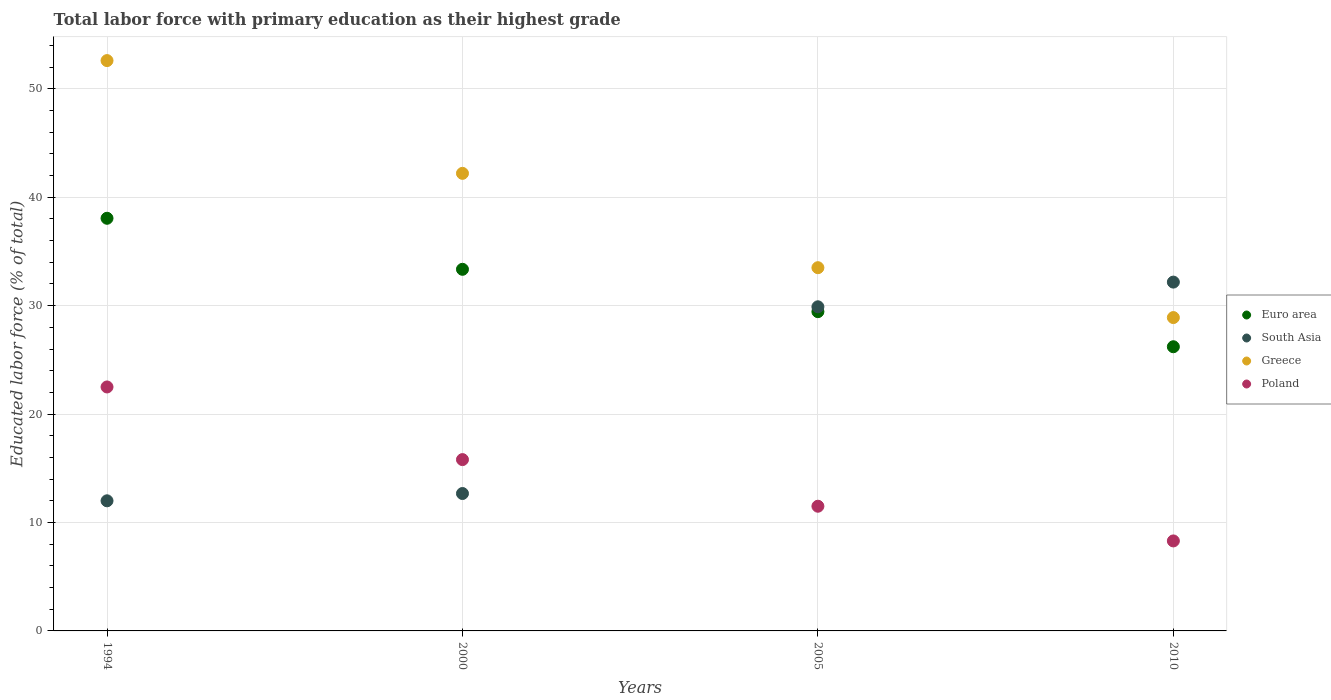How many different coloured dotlines are there?
Your answer should be very brief. 4. Is the number of dotlines equal to the number of legend labels?
Provide a succinct answer. Yes. What is the percentage of total labor force with primary education in Euro area in 2000?
Your answer should be very brief. 33.35. Across all years, what is the minimum percentage of total labor force with primary education in Greece?
Offer a very short reply. 28.9. In which year was the percentage of total labor force with primary education in South Asia minimum?
Your answer should be compact. 1994. What is the total percentage of total labor force with primary education in South Asia in the graph?
Keep it short and to the point. 86.74. What is the difference between the percentage of total labor force with primary education in Euro area in 1994 and that in 2000?
Provide a succinct answer. 4.71. What is the difference between the percentage of total labor force with primary education in Greece in 2005 and the percentage of total labor force with primary education in Euro area in 2000?
Your answer should be very brief. 0.15. What is the average percentage of total labor force with primary education in Poland per year?
Give a very brief answer. 14.53. In the year 2010, what is the difference between the percentage of total labor force with primary education in Poland and percentage of total labor force with primary education in South Asia?
Ensure brevity in your answer.  -23.87. In how many years, is the percentage of total labor force with primary education in Euro area greater than 44 %?
Provide a short and direct response. 0. What is the ratio of the percentage of total labor force with primary education in South Asia in 2000 to that in 2010?
Offer a terse response. 0.39. Is the difference between the percentage of total labor force with primary education in Poland in 1994 and 2005 greater than the difference between the percentage of total labor force with primary education in South Asia in 1994 and 2005?
Provide a short and direct response. Yes. What is the difference between the highest and the second highest percentage of total labor force with primary education in South Asia?
Make the answer very short. 2.28. What is the difference between the highest and the lowest percentage of total labor force with primary education in Euro area?
Offer a very short reply. 11.85. In how many years, is the percentage of total labor force with primary education in Poland greater than the average percentage of total labor force with primary education in Poland taken over all years?
Give a very brief answer. 2. Is it the case that in every year, the sum of the percentage of total labor force with primary education in South Asia and percentage of total labor force with primary education in Greece  is greater than the sum of percentage of total labor force with primary education in Euro area and percentage of total labor force with primary education in Poland?
Your answer should be compact. Yes. How many years are there in the graph?
Your answer should be very brief. 4. What is the difference between two consecutive major ticks on the Y-axis?
Offer a very short reply. 10. Are the values on the major ticks of Y-axis written in scientific E-notation?
Provide a short and direct response. No. Does the graph contain any zero values?
Make the answer very short. No. Does the graph contain grids?
Ensure brevity in your answer.  Yes. Where does the legend appear in the graph?
Offer a very short reply. Center right. How many legend labels are there?
Offer a very short reply. 4. What is the title of the graph?
Provide a short and direct response. Total labor force with primary education as their highest grade. Does "East Asia (developing only)" appear as one of the legend labels in the graph?
Your answer should be compact. No. What is the label or title of the Y-axis?
Keep it short and to the point. Educated labor force (% of total). What is the Educated labor force (% of total) in Euro area in 1994?
Your response must be concise. 38.06. What is the Educated labor force (% of total) in Greece in 1994?
Provide a short and direct response. 52.6. What is the Educated labor force (% of total) of Euro area in 2000?
Your answer should be compact. 33.35. What is the Educated labor force (% of total) in South Asia in 2000?
Offer a terse response. 12.67. What is the Educated labor force (% of total) in Greece in 2000?
Your response must be concise. 42.2. What is the Educated labor force (% of total) in Poland in 2000?
Your answer should be very brief. 15.8. What is the Educated labor force (% of total) of Euro area in 2005?
Provide a short and direct response. 29.44. What is the Educated labor force (% of total) of South Asia in 2005?
Keep it short and to the point. 29.89. What is the Educated labor force (% of total) in Greece in 2005?
Ensure brevity in your answer.  33.5. What is the Educated labor force (% of total) in Euro area in 2010?
Your answer should be compact. 26.21. What is the Educated labor force (% of total) in South Asia in 2010?
Your answer should be compact. 32.17. What is the Educated labor force (% of total) of Greece in 2010?
Your answer should be compact. 28.9. What is the Educated labor force (% of total) of Poland in 2010?
Ensure brevity in your answer.  8.3. Across all years, what is the maximum Educated labor force (% of total) in Euro area?
Give a very brief answer. 38.06. Across all years, what is the maximum Educated labor force (% of total) of South Asia?
Provide a succinct answer. 32.17. Across all years, what is the maximum Educated labor force (% of total) of Greece?
Your response must be concise. 52.6. Across all years, what is the maximum Educated labor force (% of total) of Poland?
Keep it short and to the point. 22.5. Across all years, what is the minimum Educated labor force (% of total) in Euro area?
Your answer should be compact. 26.21. Across all years, what is the minimum Educated labor force (% of total) in Greece?
Provide a succinct answer. 28.9. Across all years, what is the minimum Educated labor force (% of total) of Poland?
Provide a succinct answer. 8.3. What is the total Educated labor force (% of total) in Euro area in the graph?
Keep it short and to the point. 127.06. What is the total Educated labor force (% of total) in South Asia in the graph?
Ensure brevity in your answer.  86.74. What is the total Educated labor force (% of total) in Greece in the graph?
Your response must be concise. 157.2. What is the total Educated labor force (% of total) of Poland in the graph?
Make the answer very short. 58.1. What is the difference between the Educated labor force (% of total) of Euro area in 1994 and that in 2000?
Make the answer very short. 4.71. What is the difference between the Educated labor force (% of total) of South Asia in 1994 and that in 2000?
Offer a terse response. -0.67. What is the difference between the Educated labor force (% of total) of Euro area in 1994 and that in 2005?
Your answer should be compact. 8.61. What is the difference between the Educated labor force (% of total) in South Asia in 1994 and that in 2005?
Your answer should be very brief. -17.89. What is the difference between the Educated labor force (% of total) in Poland in 1994 and that in 2005?
Make the answer very short. 11. What is the difference between the Educated labor force (% of total) in Euro area in 1994 and that in 2010?
Provide a succinct answer. 11.85. What is the difference between the Educated labor force (% of total) of South Asia in 1994 and that in 2010?
Keep it short and to the point. -20.17. What is the difference between the Educated labor force (% of total) in Greece in 1994 and that in 2010?
Offer a terse response. 23.7. What is the difference between the Educated labor force (% of total) in Euro area in 2000 and that in 2005?
Provide a succinct answer. 3.91. What is the difference between the Educated labor force (% of total) in South Asia in 2000 and that in 2005?
Give a very brief answer. -17.22. What is the difference between the Educated labor force (% of total) of Greece in 2000 and that in 2005?
Make the answer very short. 8.7. What is the difference between the Educated labor force (% of total) of Poland in 2000 and that in 2005?
Provide a succinct answer. 4.3. What is the difference between the Educated labor force (% of total) of Euro area in 2000 and that in 2010?
Your answer should be very brief. 7.14. What is the difference between the Educated labor force (% of total) in South Asia in 2000 and that in 2010?
Keep it short and to the point. -19.5. What is the difference between the Educated labor force (% of total) in Poland in 2000 and that in 2010?
Provide a short and direct response. 7.5. What is the difference between the Educated labor force (% of total) of Euro area in 2005 and that in 2010?
Ensure brevity in your answer.  3.23. What is the difference between the Educated labor force (% of total) of South Asia in 2005 and that in 2010?
Ensure brevity in your answer.  -2.28. What is the difference between the Educated labor force (% of total) in Greece in 2005 and that in 2010?
Offer a very short reply. 4.6. What is the difference between the Educated labor force (% of total) in Poland in 2005 and that in 2010?
Give a very brief answer. 3.2. What is the difference between the Educated labor force (% of total) in Euro area in 1994 and the Educated labor force (% of total) in South Asia in 2000?
Offer a terse response. 25.38. What is the difference between the Educated labor force (% of total) of Euro area in 1994 and the Educated labor force (% of total) of Greece in 2000?
Your answer should be compact. -4.14. What is the difference between the Educated labor force (% of total) of Euro area in 1994 and the Educated labor force (% of total) of Poland in 2000?
Provide a short and direct response. 22.26. What is the difference between the Educated labor force (% of total) of South Asia in 1994 and the Educated labor force (% of total) of Greece in 2000?
Your answer should be very brief. -30.2. What is the difference between the Educated labor force (% of total) in Greece in 1994 and the Educated labor force (% of total) in Poland in 2000?
Your response must be concise. 36.8. What is the difference between the Educated labor force (% of total) of Euro area in 1994 and the Educated labor force (% of total) of South Asia in 2005?
Give a very brief answer. 8.16. What is the difference between the Educated labor force (% of total) of Euro area in 1994 and the Educated labor force (% of total) of Greece in 2005?
Give a very brief answer. 4.56. What is the difference between the Educated labor force (% of total) in Euro area in 1994 and the Educated labor force (% of total) in Poland in 2005?
Ensure brevity in your answer.  26.56. What is the difference between the Educated labor force (% of total) in South Asia in 1994 and the Educated labor force (% of total) in Greece in 2005?
Your answer should be compact. -21.5. What is the difference between the Educated labor force (% of total) of South Asia in 1994 and the Educated labor force (% of total) of Poland in 2005?
Your answer should be very brief. 0.5. What is the difference between the Educated labor force (% of total) in Greece in 1994 and the Educated labor force (% of total) in Poland in 2005?
Make the answer very short. 41.1. What is the difference between the Educated labor force (% of total) in Euro area in 1994 and the Educated labor force (% of total) in South Asia in 2010?
Your answer should be very brief. 5.89. What is the difference between the Educated labor force (% of total) of Euro area in 1994 and the Educated labor force (% of total) of Greece in 2010?
Provide a succinct answer. 9.16. What is the difference between the Educated labor force (% of total) of Euro area in 1994 and the Educated labor force (% of total) of Poland in 2010?
Your response must be concise. 29.76. What is the difference between the Educated labor force (% of total) in South Asia in 1994 and the Educated labor force (% of total) in Greece in 2010?
Your answer should be very brief. -16.9. What is the difference between the Educated labor force (% of total) in Greece in 1994 and the Educated labor force (% of total) in Poland in 2010?
Give a very brief answer. 44.3. What is the difference between the Educated labor force (% of total) of Euro area in 2000 and the Educated labor force (% of total) of South Asia in 2005?
Offer a terse response. 3.46. What is the difference between the Educated labor force (% of total) in Euro area in 2000 and the Educated labor force (% of total) in Greece in 2005?
Offer a terse response. -0.15. What is the difference between the Educated labor force (% of total) of Euro area in 2000 and the Educated labor force (% of total) of Poland in 2005?
Give a very brief answer. 21.85. What is the difference between the Educated labor force (% of total) in South Asia in 2000 and the Educated labor force (% of total) in Greece in 2005?
Offer a terse response. -20.83. What is the difference between the Educated labor force (% of total) in South Asia in 2000 and the Educated labor force (% of total) in Poland in 2005?
Offer a terse response. 1.17. What is the difference between the Educated labor force (% of total) in Greece in 2000 and the Educated labor force (% of total) in Poland in 2005?
Your response must be concise. 30.7. What is the difference between the Educated labor force (% of total) in Euro area in 2000 and the Educated labor force (% of total) in South Asia in 2010?
Offer a very short reply. 1.18. What is the difference between the Educated labor force (% of total) in Euro area in 2000 and the Educated labor force (% of total) in Greece in 2010?
Give a very brief answer. 4.45. What is the difference between the Educated labor force (% of total) of Euro area in 2000 and the Educated labor force (% of total) of Poland in 2010?
Offer a terse response. 25.05. What is the difference between the Educated labor force (% of total) of South Asia in 2000 and the Educated labor force (% of total) of Greece in 2010?
Ensure brevity in your answer.  -16.23. What is the difference between the Educated labor force (% of total) of South Asia in 2000 and the Educated labor force (% of total) of Poland in 2010?
Keep it short and to the point. 4.37. What is the difference between the Educated labor force (% of total) in Greece in 2000 and the Educated labor force (% of total) in Poland in 2010?
Give a very brief answer. 33.9. What is the difference between the Educated labor force (% of total) in Euro area in 2005 and the Educated labor force (% of total) in South Asia in 2010?
Ensure brevity in your answer.  -2.73. What is the difference between the Educated labor force (% of total) of Euro area in 2005 and the Educated labor force (% of total) of Greece in 2010?
Keep it short and to the point. 0.54. What is the difference between the Educated labor force (% of total) in Euro area in 2005 and the Educated labor force (% of total) in Poland in 2010?
Keep it short and to the point. 21.14. What is the difference between the Educated labor force (% of total) of South Asia in 2005 and the Educated labor force (% of total) of Poland in 2010?
Make the answer very short. 21.59. What is the difference between the Educated labor force (% of total) in Greece in 2005 and the Educated labor force (% of total) in Poland in 2010?
Make the answer very short. 25.2. What is the average Educated labor force (% of total) of Euro area per year?
Keep it short and to the point. 31.77. What is the average Educated labor force (% of total) in South Asia per year?
Give a very brief answer. 21.68. What is the average Educated labor force (% of total) in Greece per year?
Offer a very short reply. 39.3. What is the average Educated labor force (% of total) in Poland per year?
Ensure brevity in your answer.  14.53. In the year 1994, what is the difference between the Educated labor force (% of total) in Euro area and Educated labor force (% of total) in South Asia?
Keep it short and to the point. 26.06. In the year 1994, what is the difference between the Educated labor force (% of total) of Euro area and Educated labor force (% of total) of Greece?
Make the answer very short. -14.54. In the year 1994, what is the difference between the Educated labor force (% of total) in Euro area and Educated labor force (% of total) in Poland?
Your answer should be very brief. 15.56. In the year 1994, what is the difference between the Educated labor force (% of total) of South Asia and Educated labor force (% of total) of Greece?
Provide a short and direct response. -40.6. In the year 1994, what is the difference between the Educated labor force (% of total) in South Asia and Educated labor force (% of total) in Poland?
Make the answer very short. -10.5. In the year 1994, what is the difference between the Educated labor force (% of total) of Greece and Educated labor force (% of total) of Poland?
Offer a very short reply. 30.1. In the year 2000, what is the difference between the Educated labor force (% of total) of Euro area and Educated labor force (% of total) of South Asia?
Your answer should be compact. 20.68. In the year 2000, what is the difference between the Educated labor force (% of total) in Euro area and Educated labor force (% of total) in Greece?
Your answer should be very brief. -8.85. In the year 2000, what is the difference between the Educated labor force (% of total) of Euro area and Educated labor force (% of total) of Poland?
Your answer should be very brief. 17.55. In the year 2000, what is the difference between the Educated labor force (% of total) of South Asia and Educated labor force (% of total) of Greece?
Your answer should be compact. -29.53. In the year 2000, what is the difference between the Educated labor force (% of total) of South Asia and Educated labor force (% of total) of Poland?
Provide a short and direct response. -3.13. In the year 2000, what is the difference between the Educated labor force (% of total) of Greece and Educated labor force (% of total) of Poland?
Give a very brief answer. 26.4. In the year 2005, what is the difference between the Educated labor force (% of total) of Euro area and Educated labor force (% of total) of South Asia?
Your answer should be very brief. -0.45. In the year 2005, what is the difference between the Educated labor force (% of total) in Euro area and Educated labor force (% of total) in Greece?
Make the answer very short. -4.06. In the year 2005, what is the difference between the Educated labor force (% of total) of Euro area and Educated labor force (% of total) of Poland?
Your response must be concise. 17.94. In the year 2005, what is the difference between the Educated labor force (% of total) in South Asia and Educated labor force (% of total) in Greece?
Ensure brevity in your answer.  -3.61. In the year 2005, what is the difference between the Educated labor force (% of total) in South Asia and Educated labor force (% of total) in Poland?
Make the answer very short. 18.39. In the year 2005, what is the difference between the Educated labor force (% of total) of Greece and Educated labor force (% of total) of Poland?
Provide a succinct answer. 22. In the year 2010, what is the difference between the Educated labor force (% of total) in Euro area and Educated labor force (% of total) in South Asia?
Keep it short and to the point. -5.96. In the year 2010, what is the difference between the Educated labor force (% of total) in Euro area and Educated labor force (% of total) in Greece?
Provide a short and direct response. -2.69. In the year 2010, what is the difference between the Educated labor force (% of total) in Euro area and Educated labor force (% of total) in Poland?
Your answer should be very brief. 17.91. In the year 2010, what is the difference between the Educated labor force (% of total) in South Asia and Educated labor force (% of total) in Greece?
Offer a very short reply. 3.27. In the year 2010, what is the difference between the Educated labor force (% of total) in South Asia and Educated labor force (% of total) in Poland?
Provide a succinct answer. 23.87. In the year 2010, what is the difference between the Educated labor force (% of total) in Greece and Educated labor force (% of total) in Poland?
Offer a terse response. 20.6. What is the ratio of the Educated labor force (% of total) of Euro area in 1994 to that in 2000?
Offer a terse response. 1.14. What is the ratio of the Educated labor force (% of total) in South Asia in 1994 to that in 2000?
Your response must be concise. 0.95. What is the ratio of the Educated labor force (% of total) of Greece in 1994 to that in 2000?
Provide a succinct answer. 1.25. What is the ratio of the Educated labor force (% of total) of Poland in 1994 to that in 2000?
Give a very brief answer. 1.42. What is the ratio of the Educated labor force (% of total) of Euro area in 1994 to that in 2005?
Provide a short and direct response. 1.29. What is the ratio of the Educated labor force (% of total) in South Asia in 1994 to that in 2005?
Make the answer very short. 0.4. What is the ratio of the Educated labor force (% of total) in Greece in 1994 to that in 2005?
Offer a very short reply. 1.57. What is the ratio of the Educated labor force (% of total) in Poland in 1994 to that in 2005?
Offer a very short reply. 1.96. What is the ratio of the Educated labor force (% of total) of Euro area in 1994 to that in 2010?
Provide a short and direct response. 1.45. What is the ratio of the Educated labor force (% of total) of South Asia in 1994 to that in 2010?
Offer a very short reply. 0.37. What is the ratio of the Educated labor force (% of total) of Greece in 1994 to that in 2010?
Keep it short and to the point. 1.82. What is the ratio of the Educated labor force (% of total) of Poland in 1994 to that in 2010?
Make the answer very short. 2.71. What is the ratio of the Educated labor force (% of total) in Euro area in 2000 to that in 2005?
Offer a terse response. 1.13. What is the ratio of the Educated labor force (% of total) in South Asia in 2000 to that in 2005?
Your answer should be very brief. 0.42. What is the ratio of the Educated labor force (% of total) of Greece in 2000 to that in 2005?
Give a very brief answer. 1.26. What is the ratio of the Educated labor force (% of total) of Poland in 2000 to that in 2005?
Offer a very short reply. 1.37. What is the ratio of the Educated labor force (% of total) of Euro area in 2000 to that in 2010?
Provide a short and direct response. 1.27. What is the ratio of the Educated labor force (% of total) of South Asia in 2000 to that in 2010?
Keep it short and to the point. 0.39. What is the ratio of the Educated labor force (% of total) of Greece in 2000 to that in 2010?
Make the answer very short. 1.46. What is the ratio of the Educated labor force (% of total) in Poland in 2000 to that in 2010?
Make the answer very short. 1.9. What is the ratio of the Educated labor force (% of total) of Euro area in 2005 to that in 2010?
Make the answer very short. 1.12. What is the ratio of the Educated labor force (% of total) in South Asia in 2005 to that in 2010?
Your answer should be very brief. 0.93. What is the ratio of the Educated labor force (% of total) in Greece in 2005 to that in 2010?
Your answer should be compact. 1.16. What is the ratio of the Educated labor force (% of total) in Poland in 2005 to that in 2010?
Ensure brevity in your answer.  1.39. What is the difference between the highest and the second highest Educated labor force (% of total) in Euro area?
Offer a terse response. 4.71. What is the difference between the highest and the second highest Educated labor force (% of total) of South Asia?
Ensure brevity in your answer.  2.28. What is the difference between the highest and the second highest Educated labor force (% of total) in Greece?
Your answer should be very brief. 10.4. What is the difference between the highest and the second highest Educated labor force (% of total) of Poland?
Make the answer very short. 6.7. What is the difference between the highest and the lowest Educated labor force (% of total) in Euro area?
Your response must be concise. 11.85. What is the difference between the highest and the lowest Educated labor force (% of total) in South Asia?
Make the answer very short. 20.17. What is the difference between the highest and the lowest Educated labor force (% of total) in Greece?
Offer a terse response. 23.7. What is the difference between the highest and the lowest Educated labor force (% of total) in Poland?
Your response must be concise. 14.2. 